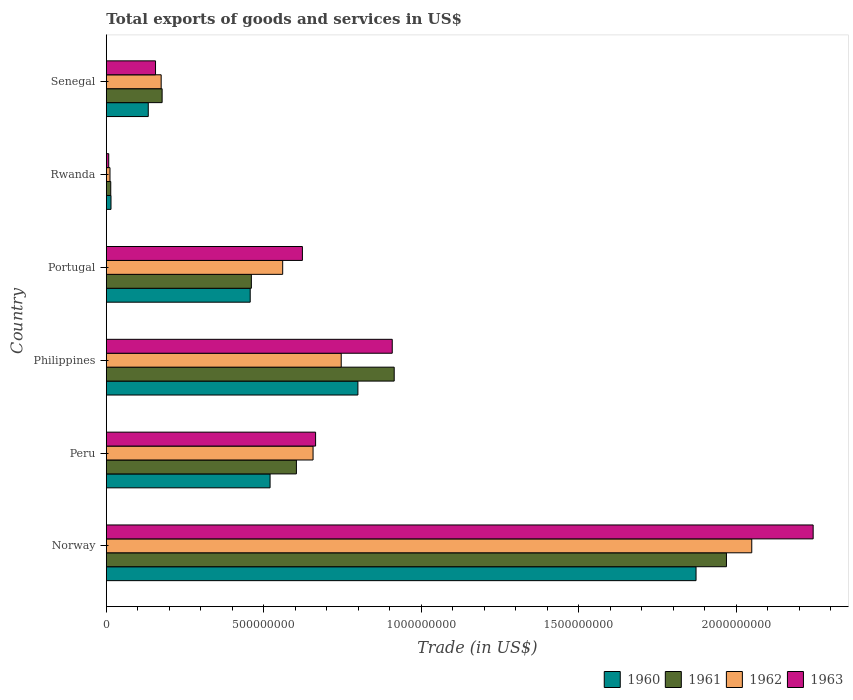How many different coloured bars are there?
Offer a very short reply. 4. How many groups of bars are there?
Provide a succinct answer. 6. How many bars are there on the 5th tick from the top?
Give a very brief answer. 4. How many bars are there on the 6th tick from the bottom?
Offer a very short reply. 4. What is the label of the 4th group of bars from the top?
Make the answer very short. Philippines. What is the total exports of goods and services in 1963 in Senegal?
Make the answer very short. 1.56e+08. Across all countries, what is the maximum total exports of goods and services in 1961?
Your answer should be very brief. 1.97e+09. Across all countries, what is the minimum total exports of goods and services in 1963?
Your answer should be very brief. 7.60e+06. In which country was the total exports of goods and services in 1962 maximum?
Your answer should be compact. Norway. In which country was the total exports of goods and services in 1960 minimum?
Ensure brevity in your answer.  Rwanda. What is the total total exports of goods and services in 1963 in the graph?
Ensure brevity in your answer.  4.60e+09. What is the difference between the total exports of goods and services in 1963 in Peru and that in Senegal?
Provide a short and direct response. 5.08e+08. What is the difference between the total exports of goods and services in 1963 in Portugal and the total exports of goods and services in 1961 in Norway?
Provide a succinct answer. -1.35e+09. What is the average total exports of goods and services in 1960 per country?
Provide a succinct answer. 6.33e+08. What is the difference between the total exports of goods and services in 1960 and total exports of goods and services in 1961 in Norway?
Your answer should be compact. -9.65e+07. What is the ratio of the total exports of goods and services in 1962 in Portugal to that in Senegal?
Provide a succinct answer. 3.22. Is the total exports of goods and services in 1961 in Norway less than that in Peru?
Ensure brevity in your answer.  No. Is the difference between the total exports of goods and services in 1960 in Peru and Philippines greater than the difference between the total exports of goods and services in 1961 in Peru and Philippines?
Keep it short and to the point. Yes. What is the difference between the highest and the second highest total exports of goods and services in 1962?
Offer a terse response. 1.30e+09. What is the difference between the highest and the lowest total exports of goods and services in 1961?
Provide a succinct answer. 1.95e+09. Is the sum of the total exports of goods and services in 1963 in Norway and Portugal greater than the maximum total exports of goods and services in 1960 across all countries?
Your answer should be compact. Yes. Is it the case that in every country, the sum of the total exports of goods and services in 1962 and total exports of goods and services in 1963 is greater than the sum of total exports of goods and services in 1960 and total exports of goods and services in 1961?
Your response must be concise. No. How many bars are there?
Make the answer very short. 24. Are all the bars in the graph horizontal?
Ensure brevity in your answer.  Yes. How many countries are there in the graph?
Ensure brevity in your answer.  6. Does the graph contain any zero values?
Ensure brevity in your answer.  No. Where does the legend appear in the graph?
Provide a succinct answer. Bottom right. How are the legend labels stacked?
Your response must be concise. Horizontal. What is the title of the graph?
Offer a very short reply. Total exports of goods and services in US$. What is the label or title of the X-axis?
Your response must be concise. Trade (in US$). What is the label or title of the Y-axis?
Make the answer very short. Country. What is the Trade (in US$) of 1960 in Norway?
Your answer should be very brief. 1.87e+09. What is the Trade (in US$) in 1961 in Norway?
Offer a terse response. 1.97e+09. What is the Trade (in US$) of 1962 in Norway?
Offer a terse response. 2.05e+09. What is the Trade (in US$) of 1963 in Norway?
Give a very brief answer. 2.24e+09. What is the Trade (in US$) in 1960 in Peru?
Give a very brief answer. 5.20e+08. What is the Trade (in US$) in 1961 in Peru?
Offer a very short reply. 6.03e+08. What is the Trade (in US$) in 1962 in Peru?
Your answer should be very brief. 6.56e+08. What is the Trade (in US$) of 1963 in Peru?
Provide a short and direct response. 6.64e+08. What is the Trade (in US$) of 1960 in Philippines?
Keep it short and to the point. 7.99e+08. What is the Trade (in US$) of 1961 in Philippines?
Ensure brevity in your answer.  9.14e+08. What is the Trade (in US$) of 1962 in Philippines?
Make the answer very short. 7.46e+08. What is the Trade (in US$) of 1963 in Philippines?
Offer a very short reply. 9.08e+08. What is the Trade (in US$) in 1960 in Portugal?
Your answer should be compact. 4.57e+08. What is the Trade (in US$) of 1961 in Portugal?
Provide a short and direct response. 4.60e+08. What is the Trade (in US$) in 1962 in Portugal?
Offer a terse response. 5.60e+08. What is the Trade (in US$) of 1963 in Portugal?
Your answer should be compact. 6.22e+08. What is the Trade (in US$) of 1960 in Rwanda?
Your response must be concise. 1.48e+07. What is the Trade (in US$) of 1961 in Rwanda?
Offer a terse response. 1.40e+07. What is the Trade (in US$) in 1962 in Rwanda?
Keep it short and to the point. 1.16e+07. What is the Trade (in US$) of 1963 in Rwanda?
Ensure brevity in your answer.  7.60e+06. What is the Trade (in US$) of 1960 in Senegal?
Keep it short and to the point. 1.33e+08. What is the Trade (in US$) in 1961 in Senegal?
Keep it short and to the point. 1.77e+08. What is the Trade (in US$) in 1962 in Senegal?
Your response must be concise. 1.74e+08. What is the Trade (in US$) of 1963 in Senegal?
Keep it short and to the point. 1.56e+08. Across all countries, what is the maximum Trade (in US$) in 1960?
Your answer should be compact. 1.87e+09. Across all countries, what is the maximum Trade (in US$) of 1961?
Offer a terse response. 1.97e+09. Across all countries, what is the maximum Trade (in US$) in 1962?
Give a very brief answer. 2.05e+09. Across all countries, what is the maximum Trade (in US$) of 1963?
Your response must be concise. 2.24e+09. Across all countries, what is the minimum Trade (in US$) of 1960?
Make the answer very short. 1.48e+07. Across all countries, what is the minimum Trade (in US$) of 1961?
Your answer should be compact. 1.40e+07. Across all countries, what is the minimum Trade (in US$) in 1962?
Your response must be concise. 1.16e+07. Across all countries, what is the minimum Trade (in US$) of 1963?
Provide a succinct answer. 7.60e+06. What is the total Trade (in US$) in 1960 in the graph?
Your answer should be compact. 3.80e+09. What is the total Trade (in US$) in 1961 in the graph?
Your response must be concise. 4.14e+09. What is the total Trade (in US$) of 1962 in the graph?
Your response must be concise. 4.20e+09. What is the total Trade (in US$) in 1963 in the graph?
Provide a short and direct response. 4.60e+09. What is the difference between the Trade (in US$) in 1960 in Norway and that in Peru?
Offer a terse response. 1.35e+09. What is the difference between the Trade (in US$) of 1961 in Norway and that in Peru?
Offer a terse response. 1.37e+09. What is the difference between the Trade (in US$) of 1962 in Norway and that in Peru?
Your answer should be compact. 1.39e+09. What is the difference between the Trade (in US$) in 1963 in Norway and that in Peru?
Provide a succinct answer. 1.58e+09. What is the difference between the Trade (in US$) of 1960 in Norway and that in Philippines?
Your answer should be very brief. 1.07e+09. What is the difference between the Trade (in US$) in 1961 in Norway and that in Philippines?
Provide a succinct answer. 1.05e+09. What is the difference between the Trade (in US$) in 1962 in Norway and that in Philippines?
Ensure brevity in your answer.  1.30e+09. What is the difference between the Trade (in US$) in 1963 in Norway and that in Philippines?
Provide a succinct answer. 1.34e+09. What is the difference between the Trade (in US$) in 1960 in Norway and that in Portugal?
Provide a short and direct response. 1.42e+09. What is the difference between the Trade (in US$) of 1961 in Norway and that in Portugal?
Give a very brief answer. 1.51e+09. What is the difference between the Trade (in US$) in 1962 in Norway and that in Portugal?
Make the answer very short. 1.49e+09. What is the difference between the Trade (in US$) of 1963 in Norway and that in Portugal?
Your response must be concise. 1.62e+09. What is the difference between the Trade (in US$) in 1960 in Norway and that in Rwanda?
Offer a very short reply. 1.86e+09. What is the difference between the Trade (in US$) in 1961 in Norway and that in Rwanda?
Your answer should be very brief. 1.95e+09. What is the difference between the Trade (in US$) in 1962 in Norway and that in Rwanda?
Make the answer very short. 2.04e+09. What is the difference between the Trade (in US$) of 1963 in Norway and that in Rwanda?
Your answer should be compact. 2.24e+09. What is the difference between the Trade (in US$) of 1960 in Norway and that in Senegal?
Provide a succinct answer. 1.74e+09. What is the difference between the Trade (in US$) of 1961 in Norway and that in Senegal?
Offer a very short reply. 1.79e+09. What is the difference between the Trade (in US$) in 1962 in Norway and that in Senegal?
Offer a very short reply. 1.87e+09. What is the difference between the Trade (in US$) of 1963 in Norway and that in Senegal?
Your answer should be very brief. 2.09e+09. What is the difference between the Trade (in US$) of 1960 in Peru and that in Philippines?
Make the answer very short. -2.79e+08. What is the difference between the Trade (in US$) in 1961 in Peru and that in Philippines?
Your answer should be compact. -3.10e+08. What is the difference between the Trade (in US$) of 1962 in Peru and that in Philippines?
Keep it short and to the point. -8.94e+07. What is the difference between the Trade (in US$) of 1963 in Peru and that in Philippines?
Make the answer very short. -2.43e+08. What is the difference between the Trade (in US$) in 1960 in Peru and that in Portugal?
Provide a short and direct response. 6.31e+07. What is the difference between the Trade (in US$) in 1961 in Peru and that in Portugal?
Offer a very short reply. 1.43e+08. What is the difference between the Trade (in US$) in 1962 in Peru and that in Portugal?
Your response must be concise. 9.64e+07. What is the difference between the Trade (in US$) of 1963 in Peru and that in Portugal?
Provide a short and direct response. 4.18e+07. What is the difference between the Trade (in US$) in 1960 in Peru and that in Rwanda?
Your answer should be very brief. 5.05e+08. What is the difference between the Trade (in US$) in 1961 in Peru and that in Rwanda?
Offer a very short reply. 5.89e+08. What is the difference between the Trade (in US$) of 1962 in Peru and that in Rwanda?
Keep it short and to the point. 6.45e+08. What is the difference between the Trade (in US$) in 1963 in Peru and that in Rwanda?
Your answer should be compact. 6.57e+08. What is the difference between the Trade (in US$) in 1960 in Peru and that in Senegal?
Offer a terse response. 3.87e+08. What is the difference between the Trade (in US$) in 1961 in Peru and that in Senegal?
Your answer should be compact. 4.26e+08. What is the difference between the Trade (in US$) of 1962 in Peru and that in Senegal?
Your response must be concise. 4.82e+08. What is the difference between the Trade (in US$) of 1963 in Peru and that in Senegal?
Your answer should be compact. 5.08e+08. What is the difference between the Trade (in US$) in 1960 in Philippines and that in Portugal?
Keep it short and to the point. 3.42e+08. What is the difference between the Trade (in US$) in 1961 in Philippines and that in Portugal?
Your answer should be very brief. 4.53e+08. What is the difference between the Trade (in US$) of 1962 in Philippines and that in Portugal?
Offer a very short reply. 1.86e+08. What is the difference between the Trade (in US$) in 1963 in Philippines and that in Portugal?
Make the answer very short. 2.85e+08. What is the difference between the Trade (in US$) in 1960 in Philippines and that in Rwanda?
Ensure brevity in your answer.  7.84e+08. What is the difference between the Trade (in US$) in 1961 in Philippines and that in Rwanda?
Offer a terse response. 9.00e+08. What is the difference between the Trade (in US$) in 1962 in Philippines and that in Rwanda?
Give a very brief answer. 7.34e+08. What is the difference between the Trade (in US$) of 1963 in Philippines and that in Rwanda?
Ensure brevity in your answer.  9.00e+08. What is the difference between the Trade (in US$) of 1960 in Philippines and that in Senegal?
Make the answer very short. 6.66e+08. What is the difference between the Trade (in US$) of 1961 in Philippines and that in Senegal?
Offer a very short reply. 7.37e+08. What is the difference between the Trade (in US$) of 1962 in Philippines and that in Senegal?
Make the answer very short. 5.72e+08. What is the difference between the Trade (in US$) in 1963 in Philippines and that in Senegal?
Offer a terse response. 7.51e+08. What is the difference between the Trade (in US$) of 1960 in Portugal and that in Rwanda?
Provide a short and direct response. 4.42e+08. What is the difference between the Trade (in US$) of 1961 in Portugal and that in Rwanda?
Keep it short and to the point. 4.46e+08. What is the difference between the Trade (in US$) in 1962 in Portugal and that in Rwanda?
Keep it short and to the point. 5.48e+08. What is the difference between the Trade (in US$) in 1963 in Portugal and that in Rwanda?
Provide a short and direct response. 6.15e+08. What is the difference between the Trade (in US$) of 1960 in Portugal and that in Senegal?
Offer a terse response. 3.24e+08. What is the difference between the Trade (in US$) in 1961 in Portugal and that in Senegal?
Provide a succinct answer. 2.83e+08. What is the difference between the Trade (in US$) in 1962 in Portugal and that in Senegal?
Provide a succinct answer. 3.86e+08. What is the difference between the Trade (in US$) in 1963 in Portugal and that in Senegal?
Your answer should be very brief. 4.66e+08. What is the difference between the Trade (in US$) in 1960 in Rwanda and that in Senegal?
Provide a short and direct response. -1.18e+08. What is the difference between the Trade (in US$) of 1961 in Rwanda and that in Senegal?
Give a very brief answer. -1.63e+08. What is the difference between the Trade (in US$) of 1962 in Rwanda and that in Senegal?
Ensure brevity in your answer.  -1.62e+08. What is the difference between the Trade (in US$) of 1963 in Rwanda and that in Senegal?
Your response must be concise. -1.49e+08. What is the difference between the Trade (in US$) of 1960 in Norway and the Trade (in US$) of 1961 in Peru?
Keep it short and to the point. 1.27e+09. What is the difference between the Trade (in US$) in 1960 in Norway and the Trade (in US$) in 1962 in Peru?
Offer a terse response. 1.22e+09. What is the difference between the Trade (in US$) in 1960 in Norway and the Trade (in US$) in 1963 in Peru?
Provide a short and direct response. 1.21e+09. What is the difference between the Trade (in US$) of 1961 in Norway and the Trade (in US$) of 1962 in Peru?
Offer a terse response. 1.31e+09. What is the difference between the Trade (in US$) of 1961 in Norway and the Trade (in US$) of 1963 in Peru?
Provide a succinct answer. 1.30e+09. What is the difference between the Trade (in US$) of 1962 in Norway and the Trade (in US$) of 1963 in Peru?
Keep it short and to the point. 1.38e+09. What is the difference between the Trade (in US$) of 1960 in Norway and the Trade (in US$) of 1961 in Philippines?
Ensure brevity in your answer.  9.58e+08. What is the difference between the Trade (in US$) of 1960 in Norway and the Trade (in US$) of 1962 in Philippines?
Your response must be concise. 1.13e+09. What is the difference between the Trade (in US$) of 1960 in Norway and the Trade (in US$) of 1963 in Philippines?
Offer a very short reply. 9.64e+08. What is the difference between the Trade (in US$) in 1961 in Norway and the Trade (in US$) in 1962 in Philippines?
Give a very brief answer. 1.22e+09. What is the difference between the Trade (in US$) of 1961 in Norway and the Trade (in US$) of 1963 in Philippines?
Keep it short and to the point. 1.06e+09. What is the difference between the Trade (in US$) in 1962 in Norway and the Trade (in US$) in 1963 in Philippines?
Your answer should be compact. 1.14e+09. What is the difference between the Trade (in US$) in 1960 in Norway and the Trade (in US$) in 1961 in Portugal?
Provide a short and direct response. 1.41e+09. What is the difference between the Trade (in US$) of 1960 in Norway and the Trade (in US$) of 1962 in Portugal?
Offer a terse response. 1.31e+09. What is the difference between the Trade (in US$) in 1960 in Norway and the Trade (in US$) in 1963 in Portugal?
Your answer should be very brief. 1.25e+09. What is the difference between the Trade (in US$) in 1961 in Norway and the Trade (in US$) in 1962 in Portugal?
Give a very brief answer. 1.41e+09. What is the difference between the Trade (in US$) of 1961 in Norway and the Trade (in US$) of 1963 in Portugal?
Your answer should be very brief. 1.35e+09. What is the difference between the Trade (in US$) in 1962 in Norway and the Trade (in US$) in 1963 in Portugal?
Ensure brevity in your answer.  1.43e+09. What is the difference between the Trade (in US$) of 1960 in Norway and the Trade (in US$) of 1961 in Rwanda?
Make the answer very short. 1.86e+09. What is the difference between the Trade (in US$) in 1960 in Norway and the Trade (in US$) in 1962 in Rwanda?
Your answer should be very brief. 1.86e+09. What is the difference between the Trade (in US$) of 1960 in Norway and the Trade (in US$) of 1963 in Rwanda?
Your response must be concise. 1.86e+09. What is the difference between the Trade (in US$) of 1961 in Norway and the Trade (in US$) of 1962 in Rwanda?
Make the answer very short. 1.96e+09. What is the difference between the Trade (in US$) in 1961 in Norway and the Trade (in US$) in 1963 in Rwanda?
Make the answer very short. 1.96e+09. What is the difference between the Trade (in US$) in 1962 in Norway and the Trade (in US$) in 1963 in Rwanda?
Provide a short and direct response. 2.04e+09. What is the difference between the Trade (in US$) in 1960 in Norway and the Trade (in US$) in 1961 in Senegal?
Offer a very short reply. 1.69e+09. What is the difference between the Trade (in US$) of 1960 in Norway and the Trade (in US$) of 1962 in Senegal?
Provide a short and direct response. 1.70e+09. What is the difference between the Trade (in US$) of 1960 in Norway and the Trade (in US$) of 1963 in Senegal?
Offer a terse response. 1.72e+09. What is the difference between the Trade (in US$) in 1961 in Norway and the Trade (in US$) in 1962 in Senegal?
Make the answer very short. 1.79e+09. What is the difference between the Trade (in US$) in 1961 in Norway and the Trade (in US$) in 1963 in Senegal?
Your response must be concise. 1.81e+09. What is the difference between the Trade (in US$) of 1962 in Norway and the Trade (in US$) of 1963 in Senegal?
Keep it short and to the point. 1.89e+09. What is the difference between the Trade (in US$) in 1960 in Peru and the Trade (in US$) in 1961 in Philippines?
Offer a terse response. -3.94e+08. What is the difference between the Trade (in US$) of 1960 in Peru and the Trade (in US$) of 1962 in Philippines?
Your response must be concise. -2.26e+08. What is the difference between the Trade (in US$) of 1960 in Peru and the Trade (in US$) of 1963 in Philippines?
Your response must be concise. -3.88e+08. What is the difference between the Trade (in US$) of 1961 in Peru and the Trade (in US$) of 1962 in Philippines?
Offer a very short reply. -1.42e+08. What is the difference between the Trade (in US$) of 1961 in Peru and the Trade (in US$) of 1963 in Philippines?
Your response must be concise. -3.04e+08. What is the difference between the Trade (in US$) in 1962 in Peru and the Trade (in US$) in 1963 in Philippines?
Give a very brief answer. -2.51e+08. What is the difference between the Trade (in US$) of 1960 in Peru and the Trade (in US$) of 1961 in Portugal?
Your answer should be very brief. 5.94e+07. What is the difference between the Trade (in US$) in 1960 in Peru and the Trade (in US$) in 1962 in Portugal?
Give a very brief answer. -4.00e+07. What is the difference between the Trade (in US$) of 1960 in Peru and the Trade (in US$) of 1963 in Portugal?
Ensure brevity in your answer.  -1.03e+08. What is the difference between the Trade (in US$) in 1961 in Peru and the Trade (in US$) in 1962 in Portugal?
Offer a terse response. 4.35e+07. What is the difference between the Trade (in US$) in 1961 in Peru and the Trade (in US$) in 1963 in Portugal?
Your answer should be very brief. -1.91e+07. What is the difference between the Trade (in US$) of 1962 in Peru and the Trade (in US$) of 1963 in Portugal?
Ensure brevity in your answer.  3.38e+07. What is the difference between the Trade (in US$) in 1960 in Peru and the Trade (in US$) in 1961 in Rwanda?
Offer a terse response. 5.06e+08. What is the difference between the Trade (in US$) in 1960 in Peru and the Trade (in US$) in 1962 in Rwanda?
Ensure brevity in your answer.  5.08e+08. What is the difference between the Trade (in US$) in 1960 in Peru and the Trade (in US$) in 1963 in Rwanda?
Offer a very short reply. 5.12e+08. What is the difference between the Trade (in US$) in 1961 in Peru and the Trade (in US$) in 1962 in Rwanda?
Provide a short and direct response. 5.92e+08. What is the difference between the Trade (in US$) of 1961 in Peru and the Trade (in US$) of 1963 in Rwanda?
Offer a terse response. 5.96e+08. What is the difference between the Trade (in US$) in 1962 in Peru and the Trade (in US$) in 1963 in Rwanda?
Ensure brevity in your answer.  6.49e+08. What is the difference between the Trade (in US$) of 1960 in Peru and the Trade (in US$) of 1961 in Senegal?
Make the answer very short. 3.43e+08. What is the difference between the Trade (in US$) in 1960 in Peru and the Trade (in US$) in 1962 in Senegal?
Your response must be concise. 3.46e+08. What is the difference between the Trade (in US$) in 1960 in Peru and the Trade (in US$) in 1963 in Senegal?
Provide a short and direct response. 3.64e+08. What is the difference between the Trade (in US$) of 1961 in Peru and the Trade (in US$) of 1962 in Senegal?
Make the answer very short. 4.29e+08. What is the difference between the Trade (in US$) in 1961 in Peru and the Trade (in US$) in 1963 in Senegal?
Offer a very short reply. 4.47e+08. What is the difference between the Trade (in US$) in 1962 in Peru and the Trade (in US$) in 1963 in Senegal?
Offer a very short reply. 5.00e+08. What is the difference between the Trade (in US$) in 1960 in Philippines and the Trade (in US$) in 1961 in Portugal?
Ensure brevity in your answer.  3.38e+08. What is the difference between the Trade (in US$) in 1960 in Philippines and the Trade (in US$) in 1962 in Portugal?
Ensure brevity in your answer.  2.39e+08. What is the difference between the Trade (in US$) of 1960 in Philippines and the Trade (in US$) of 1963 in Portugal?
Offer a very short reply. 1.76e+08. What is the difference between the Trade (in US$) in 1961 in Philippines and the Trade (in US$) in 1962 in Portugal?
Ensure brevity in your answer.  3.54e+08. What is the difference between the Trade (in US$) in 1961 in Philippines and the Trade (in US$) in 1963 in Portugal?
Give a very brief answer. 2.91e+08. What is the difference between the Trade (in US$) in 1962 in Philippines and the Trade (in US$) in 1963 in Portugal?
Offer a very short reply. 1.23e+08. What is the difference between the Trade (in US$) of 1960 in Philippines and the Trade (in US$) of 1961 in Rwanda?
Provide a short and direct response. 7.85e+08. What is the difference between the Trade (in US$) in 1960 in Philippines and the Trade (in US$) in 1962 in Rwanda?
Ensure brevity in your answer.  7.87e+08. What is the difference between the Trade (in US$) in 1960 in Philippines and the Trade (in US$) in 1963 in Rwanda?
Offer a terse response. 7.91e+08. What is the difference between the Trade (in US$) in 1961 in Philippines and the Trade (in US$) in 1962 in Rwanda?
Make the answer very short. 9.02e+08. What is the difference between the Trade (in US$) in 1961 in Philippines and the Trade (in US$) in 1963 in Rwanda?
Provide a short and direct response. 9.06e+08. What is the difference between the Trade (in US$) of 1962 in Philippines and the Trade (in US$) of 1963 in Rwanda?
Your answer should be compact. 7.38e+08. What is the difference between the Trade (in US$) of 1960 in Philippines and the Trade (in US$) of 1961 in Senegal?
Provide a succinct answer. 6.22e+08. What is the difference between the Trade (in US$) of 1960 in Philippines and the Trade (in US$) of 1962 in Senegal?
Make the answer very short. 6.25e+08. What is the difference between the Trade (in US$) of 1960 in Philippines and the Trade (in US$) of 1963 in Senegal?
Ensure brevity in your answer.  6.42e+08. What is the difference between the Trade (in US$) of 1961 in Philippines and the Trade (in US$) of 1962 in Senegal?
Give a very brief answer. 7.40e+08. What is the difference between the Trade (in US$) of 1961 in Philippines and the Trade (in US$) of 1963 in Senegal?
Ensure brevity in your answer.  7.58e+08. What is the difference between the Trade (in US$) of 1962 in Philippines and the Trade (in US$) of 1963 in Senegal?
Offer a terse response. 5.90e+08. What is the difference between the Trade (in US$) of 1960 in Portugal and the Trade (in US$) of 1961 in Rwanda?
Offer a very short reply. 4.43e+08. What is the difference between the Trade (in US$) in 1960 in Portugal and the Trade (in US$) in 1962 in Rwanda?
Give a very brief answer. 4.45e+08. What is the difference between the Trade (in US$) in 1960 in Portugal and the Trade (in US$) in 1963 in Rwanda?
Your response must be concise. 4.49e+08. What is the difference between the Trade (in US$) in 1961 in Portugal and the Trade (in US$) in 1962 in Rwanda?
Your response must be concise. 4.49e+08. What is the difference between the Trade (in US$) in 1961 in Portugal and the Trade (in US$) in 1963 in Rwanda?
Provide a short and direct response. 4.53e+08. What is the difference between the Trade (in US$) of 1962 in Portugal and the Trade (in US$) of 1963 in Rwanda?
Keep it short and to the point. 5.52e+08. What is the difference between the Trade (in US$) in 1960 in Portugal and the Trade (in US$) in 1961 in Senegal?
Give a very brief answer. 2.80e+08. What is the difference between the Trade (in US$) in 1960 in Portugal and the Trade (in US$) in 1962 in Senegal?
Keep it short and to the point. 2.83e+08. What is the difference between the Trade (in US$) in 1960 in Portugal and the Trade (in US$) in 1963 in Senegal?
Your response must be concise. 3.01e+08. What is the difference between the Trade (in US$) in 1961 in Portugal and the Trade (in US$) in 1962 in Senegal?
Your answer should be compact. 2.86e+08. What is the difference between the Trade (in US$) of 1961 in Portugal and the Trade (in US$) of 1963 in Senegal?
Offer a terse response. 3.04e+08. What is the difference between the Trade (in US$) of 1962 in Portugal and the Trade (in US$) of 1963 in Senegal?
Provide a succinct answer. 4.04e+08. What is the difference between the Trade (in US$) of 1960 in Rwanda and the Trade (in US$) of 1961 in Senegal?
Your answer should be compact. -1.62e+08. What is the difference between the Trade (in US$) of 1960 in Rwanda and the Trade (in US$) of 1962 in Senegal?
Give a very brief answer. -1.59e+08. What is the difference between the Trade (in US$) in 1960 in Rwanda and the Trade (in US$) in 1963 in Senegal?
Provide a succinct answer. -1.41e+08. What is the difference between the Trade (in US$) in 1961 in Rwanda and the Trade (in US$) in 1962 in Senegal?
Offer a very short reply. -1.60e+08. What is the difference between the Trade (in US$) of 1961 in Rwanda and the Trade (in US$) of 1963 in Senegal?
Offer a terse response. -1.42e+08. What is the difference between the Trade (in US$) of 1962 in Rwanda and the Trade (in US$) of 1963 in Senegal?
Offer a very short reply. -1.45e+08. What is the average Trade (in US$) in 1960 per country?
Offer a terse response. 6.33e+08. What is the average Trade (in US$) in 1961 per country?
Offer a terse response. 6.90e+08. What is the average Trade (in US$) in 1962 per country?
Offer a very short reply. 6.99e+08. What is the average Trade (in US$) of 1963 per country?
Your answer should be very brief. 7.67e+08. What is the difference between the Trade (in US$) of 1960 and Trade (in US$) of 1961 in Norway?
Keep it short and to the point. -9.65e+07. What is the difference between the Trade (in US$) in 1960 and Trade (in US$) in 1962 in Norway?
Provide a succinct answer. -1.77e+08. What is the difference between the Trade (in US$) in 1960 and Trade (in US$) in 1963 in Norway?
Keep it short and to the point. -3.72e+08. What is the difference between the Trade (in US$) of 1961 and Trade (in US$) of 1962 in Norway?
Ensure brevity in your answer.  -8.04e+07. What is the difference between the Trade (in US$) of 1961 and Trade (in US$) of 1963 in Norway?
Provide a short and direct response. -2.75e+08. What is the difference between the Trade (in US$) of 1962 and Trade (in US$) of 1963 in Norway?
Give a very brief answer. -1.95e+08. What is the difference between the Trade (in US$) of 1960 and Trade (in US$) of 1961 in Peru?
Offer a terse response. -8.36e+07. What is the difference between the Trade (in US$) of 1960 and Trade (in US$) of 1962 in Peru?
Make the answer very short. -1.36e+08. What is the difference between the Trade (in US$) in 1960 and Trade (in US$) in 1963 in Peru?
Ensure brevity in your answer.  -1.44e+08. What is the difference between the Trade (in US$) of 1961 and Trade (in US$) of 1962 in Peru?
Ensure brevity in your answer.  -5.29e+07. What is the difference between the Trade (in US$) of 1961 and Trade (in US$) of 1963 in Peru?
Make the answer very short. -6.09e+07. What is the difference between the Trade (in US$) in 1962 and Trade (in US$) in 1963 in Peru?
Ensure brevity in your answer.  -8.02e+06. What is the difference between the Trade (in US$) of 1960 and Trade (in US$) of 1961 in Philippines?
Offer a very short reply. -1.15e+08. What is the difference between the Trade (in US$) in 1960 and Trade (in US$) in 1962 in Philippines?
Your response must be concise. 5.30e+07. What is the difference between the Trade (in US$) in 1960 and Trade (in US$) in 1963 in Philippines?
Provide a succinct answer. -1.09e+08. What is the difference between the Trade (in US$) in 1961 and Trade (in US$) in 1962 in Philippines?
Your answer should be compact. 1.68e+08. What is the difference between the Trade (in US$) in 1961 and Trade (in US$) in 1963 in Philippines?
Provide a short and direct response. 6.20e+06. What is the difference between the Trade (in US$) in 1962 and Trade (in US$) in 1963 in Philippines?
Ensure brevity in your answer.  -1.62e+08. What is the difference between the Trade (in US$) of 1960 and Trade (in US$) of 1961 in Portugal?
Give a very brief answer. -3.68e+06. What is the difference between the Trade (in US$) of 1960 and Trade (in US$) of 1962 in Portugal?
Your answer should be compact. -1.03e+08. What is the difference between the Trade (in US$) in 1960 and Trade (in US$) in 1963 in Portugal?
Ensure brevity in your answer.  -1.66e+08. What is the difference between the Trade (in US$) of 1961 and Trade (in US$) of 1962 in Portugal?
Ensure brevity in your answer.  -9.94e+07. What is the difference between the Trade (in US$) in 1961 and Trade (in US$) in 1963 in Portugal?
Offer a terse response. -1.62e+08. What is the difference between the Trade (in US$) in 1962 and Trade (in US$) in 1963 in Portugal?
Offer a terse response. -6.26e+07. What is the difference between the Trade (in US$) of 1960 and Trade (in US$) of 1961 in Rwanda?
Your response must be concise. 8.00e+05. What is the difference between the Trade (in US$) of 1960 and Trade (in US$) of 1962 in Rwanda?
Ensure brevity in your answer.  3.20e+06. What is the difference between the Trade (in US$) in 1960 and Trade (in US$) in 1963 in Rwanda?
Your response must be concise. 7.20e+06. What is the difference between the Trade (in US$) of 1961 and Trade (in US$) of 1962 in Rwanda?
Offer a terse response. 2.40e+06. What is the difference between the Trade (in US$) in 1961 and Trade (in US$) in 1963 in Rwanda?
Offer a terse response. 6.40e+06. What is the difference between the Trade (in US$) in 1962 and Trade (in US$) in 1963 in Rwanda?
Ensure brevity in your answer.  4.00e+06. What is the difference between the Trade (in US$) of 1960 and Trade (in US$) of 1961 in Senegal?
Your answer should be compact. -4.40e+07. What is the difference between the Trade (in US$) in 1960 and Trade (in US$) in 1962 in Senegal?
Your answer should be compact. -4.09e+07. What is the difference between the Trade (in US$) in 1960 and Trade (in US$) in 1963 in Senegal?
Give a very brief answer. -2.30e+07. What is the difference between the Trade (in US$) of 1961 and Trade (in US$) of 1962 in Senegal?
Ensure brevity in your answer.  3.05e+06. What is the difference between the Trade (in US$) in 1961 and Trade (in US$) in 1963 in Senegal?
Offer a very short reply. 2.10e+07. What is the difference between the Trade (in US$) in 1962 and Trade (in US$) in 1963 in Senegal?
Provide a short and direct response. 1.79e+07. What is the ratio of the Trade (in US$) in 1960 in Norway to that in Peru?
Ensure brevity in your answer.  3.6. What is the ratio of the Trade (in US$) of 1961 in Norway to that in Peru?
Your answer should be very brief. 3.26. What is the ratio of the Trade (in US$) of 1962 in Norway to that in Peru?
Provide a succinct answer. 3.12. What is the ratio of the Trade (in US$) in 1963 in Norway to that in Peru?
Offer a terse response. 3.38. What is the ratio of the Trade (in US$) of 1960 in Norway to that in Philippines?
Offer a very short reply. 2.34. What is the ratio of the Trade (in US$) of 1961 in Norway to that in Philippines?
Your response must be concise. 2.15. What is the ratio of the Trade (in US$) of 1962 in Norway to that in Philippines?
Keep it short and to the point. 2.75. What is the ratio of the Trade (in US$) of 1963 in Norway to that in Philippines?
Offer a terse response. 2.47. What is the ratio of the Trade (in US$) in 1960 in Norway to that in Portugal?
Make the answer very short. 4.1. What is the ratio of the Trade (in US$) in 1961 in Norway to that in Portugal?
Offer a very short reply. 4.28. What is the ratio of the Trade (in US$) of 1962 in Norway to that in Portugal?
Your answer should be very brief. 3.66. What is the ratio of the Trade (in US$) in 1963 in Norway to that in Portugal?
Offer a terse response. 3.6. What is the ratio of the Trade (in US$) of 1960 in Norway to that in Rwanda?
Provide a succinct answer. 126.49. What is the ratio of the Trade (in US$) of 1961 in Norway to that in Rwanda?
Give a very brief answer. 140.61. What is the ratio of the Trade (in US$) in 1962 in Norway to that in Rwanda?
Provide a short and direct response. 176.63. What is the ratio of the Trade (in US$) in 1963 in Norway to that in Rwanda?
Provide a succinct answer. 295.24. What is the ratio of the Trade (in US$) in 1960 in Norway to that in Senegal?
Ensure brevity in your answer.  14.06. What is the ratio of the Trade (in US$) in 1961 in Norway to that in Senegal?
Provide a short and direct response. 11.11. What is the ratio of the Trade (in US$) in 1962 in Norway to that in Senegal?
Give a very brief answer. 11.77. What is the ratio of the Trade (in US$) of 1963 in Norway to that in Senegal?
Your answer should be very brief. 14.37. What is the ratio of the Trade (in US$) in 1960 in Peru to that in Philippines?
Provide a succinct answer. 0.65. What is the ratio of the Trade (in US$) in 1961 in Peru to that in Philippines?
Make the answer very short. 0.66. What is the ratio of the Trade (in US$) in 1962 in Peru to that in Philippines?
Provide a short and direct response. 0.88. What is the ratio of the Trade (in US$) in 1963 in Peru to that in Philippines?
Provide a short and direct response. 0.73. What is the ratio of the Trade (in US$) of 1960 in Peru to that in Portugal?
Your answer should be very brief. 1.14. What is the ratio of the Trade (in US$) of 1961 in Peru to that in Portugal?
Keep it short and to the point. 1.31. What is the ratio of the Trade (in US$) of 1962 in Peru to that in Portugal?
Offer a very short reply. 1.17. What is the ratio of the Trade (in US$) in 1963 in Peru to that in Portugal?
Offer a terse response. 1.07. What is the ratio of the Trade (in US$) of 1960 in Peru to that in Rwanda?
Give a very brief answer. 35.12. What is the ratio of the Trade (in US$) of 1961 in Peru to that in Rwanda?
Provide a succinct answer. 43.1. What is the ratio of the Trade (in US$) in 1962 in Peru to that in Rwanda?
Offer a terse response. 56.57. What is the ratio of the Trade (in US$) of 1963 in Peru to that in Rwanda?
Provide a succinct answer. 87.41. What is the ratio of the Trade (in US$) in 1960 in Peru to that in Senegal?
Your answer should be compact. 3.9. What is the ratio of the Trade (in US$) in 1961 in Peru to that in Senegal?
Your response must be concise. 3.41. What is the ratio of the Trade (in US$) in 1962 in Peru to that in Senegal?
Give a very brief answer. 3.77. What is the ratio of the Trade (in US$) of 1963 in Peru to that in Senegal?
Your answer should be very brief. 4.25. What is the ratio of the Trade (in US$) in 1960 in Philippines to that in Portugal?
Offer a very short reply. 1.75. What is the ratio of the Trade (in US$) in 1961 in Philippines to that in Portugal?
Give a very brief answer. 1.98. What is the ratio of the Trade (in US$) of 1962 in Philippines to that in Portugal?
Provide a succinct answer. 1.33. What is the ratio of the Trade (in US$) of 1963 in Philippines to that in Portugal?
Offer a very short reply. 1.46. What is the ratio of the Trade (in US$) in 1960 in Philippines to that in Rwanda?
Your answer should be compact. 53.96. What is the ratio of the Trade (in US$) in 1961 in Philippines to that in Rwanda?
Your answer should be compact. 65.27. What is the ratio of the Trade (in US$) of 1962 in Philippines to that in Rwanda?
Offer a very short reply. 64.28. What is the ratio of the Trade (in US$) of 1963 in Philippines to that in Rwanda?
Provide a short and direct response. 119.43. What is the ratio of the Trade (in US$) of 1960 in Philippines to that in Senegal?
Keep it short and to the point. 6. What is the ratio of the Trade (in US$) in 1961 in Philippines to that in Senegal?
Your response must be concise. 5.16. What is the ratio of the Trade (in US$) in 1962 in Philippines to that in Senegal?
Provide a succinct answer. 4.28. What is the ratio of the Trade (in US$) in 1963 in Philippines to that in Senegal?
Give a very brief answer. 5.81. What is the ratio of the Trade (in US$) of 1960 in Portugal to that in Rwanda?
Ensure brevity in your answer.  30.86. What is the ratio of the Trade (in US$) in 1961 in Portugal to that in Rwanda?
Provide a short and direct response. 32.89. What is the ratio of the Trade (in US$) of 1962 in Portugal to that in Rwanda?
Offer a very short reply. 48.26. What is the ratio of the Trade (in US$) of 1963 in Portugal to that in Rwanda?
Keep it short and to the point. 81.9. What is the ratio of the Trade (in US$) in 1960 in Portugal to that in Senegal?
Offer a terse response. 3.43. What is the ratio of the Trade (in US$) in 1961 in Portugal to that in Senegal?
Provide a succinct answer. 2.6. What is the ratio of the Trade (in US$) of 1962 in Portugal to that in Senegal?
Your answer should be compact. 3.22. What is the ratio of the Trade (in US$) in 1963 in Portugal to that in Senegal?
Give a very brief answer. 3.99. What is the ratio of the Trade (in US$) in 1960 in Rwanda to that in Senegal?
Ensure brevity in your answer.  0.11. What is the ratio of the Trade (in US$) in 1961 in Rwanda to that in Senegal?
Keep it short and to the point. 0.08. What is the ratio of the Trade (in US$) of 1962 in Rwanda to that in Senegal?
Offer a very short reply. 0.07. What is the ratio of the Trade (in US$) in 1963 in Rwanda to that in Senegal?
Provide a short and direct response. 0.05. What is the difference between the highest and the second highest Trade (in US$) of 1960?
Your response must be concise. 1.07e+09. What is the difference between the highest and the second highest Trade (in US$) in 1961?
Provide a succinct answer. 1.05e+09. What is the difference between the highest and the second highest Trade (in US$) in 1962?
Provide a succinct answer. 1.30e+09. What is the difference between the highest and the second highest Trade (in US$) in 1963?
Keep it short and to the point. 1.34e+09. What is the difference between the highest and the lowest Trade (in US$) of 1960?
Provide a succinct answer. 1.86e+09. What is the difference between the highest and the lowest Trade (in US$) in 1961?
Your answer should be compact. 1.95e+09. What is the difference between the highest and the lowest Trade (in US$) in 1962?
Offer a terse response. 2.04e+09. What is the difference between the highest and the lowest Trade (in US$) of 1963?
Ensure brevity in your answer.  2.24e+09. 